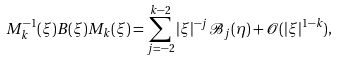<formula> <loc_0><loc_0><loc_500><loc_500>M _ { k } ^ { - 1 } ( \xi ) B ( \xi ) M _ { k } ( \xi ) = \sum _ { j = - 2 } ^ { k - 2 } | \xi | ^ { - j } \mathcal { B } _ { j } ( \eta ) + \mathcal { O } ( | \xi | ^ { 1 - k } ) ,</formula> 